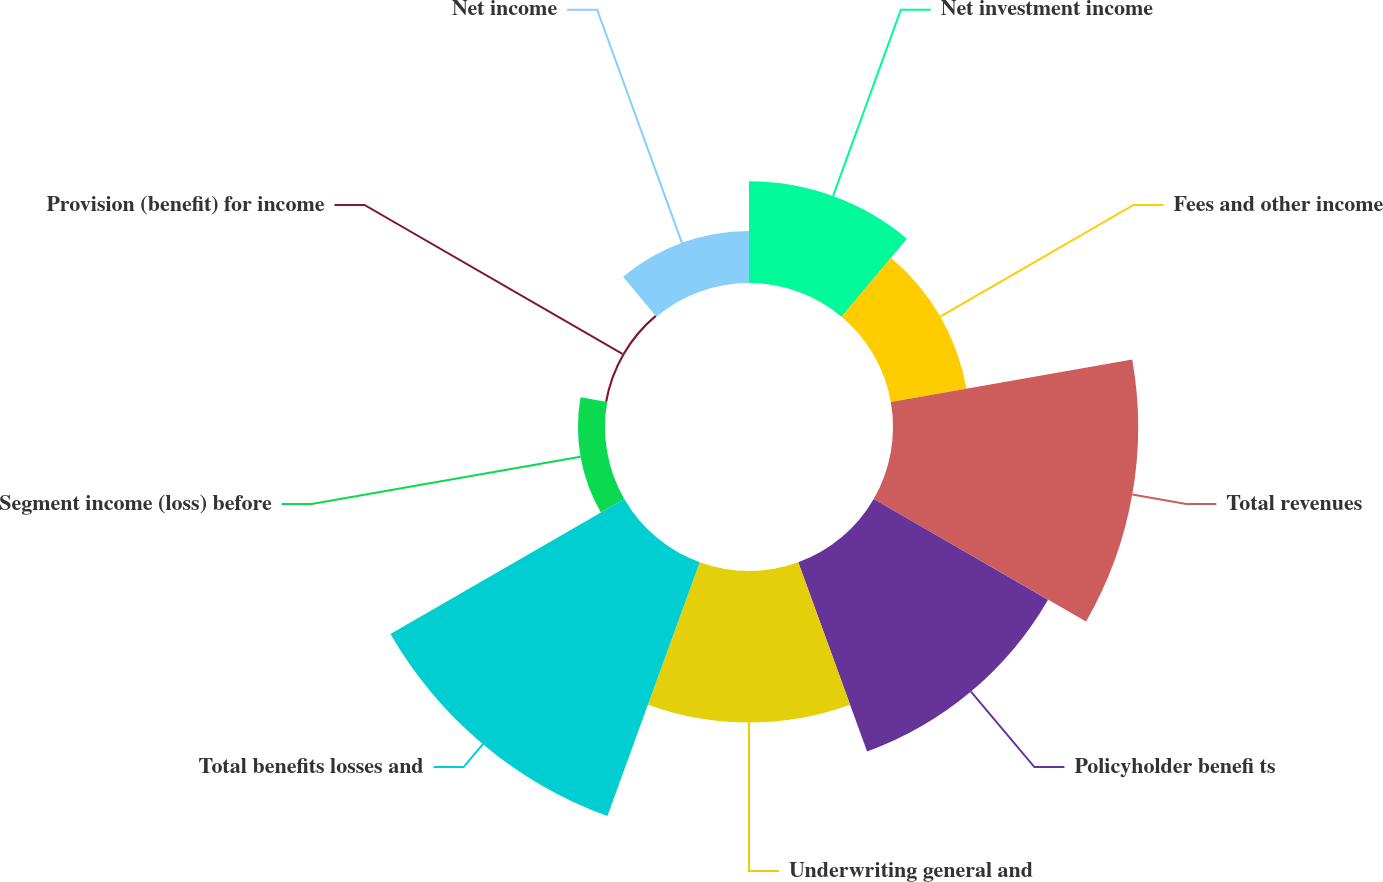<chart> <loc_0><loc_0><loc_500><loc_500><pie_chart><fcel>Net investment income<fcel>Fees and other income<fcel>Total revenues<fcel>Policyholder benefi ts<fcel>Underwriting general and<fcel>Total benefits losses and<fcel>Segment income (loss) before<fcel>Provision (benefit) for income<fcel>Net income<nl><fcel>9.02%<fcel>6.81%<fcel>21.74%<fcel>17.85%<fcel>13.44%<fcel>23.94%<fcel>2.4%<fcel>0.19%<fcel>4.61%<nl></chart> 